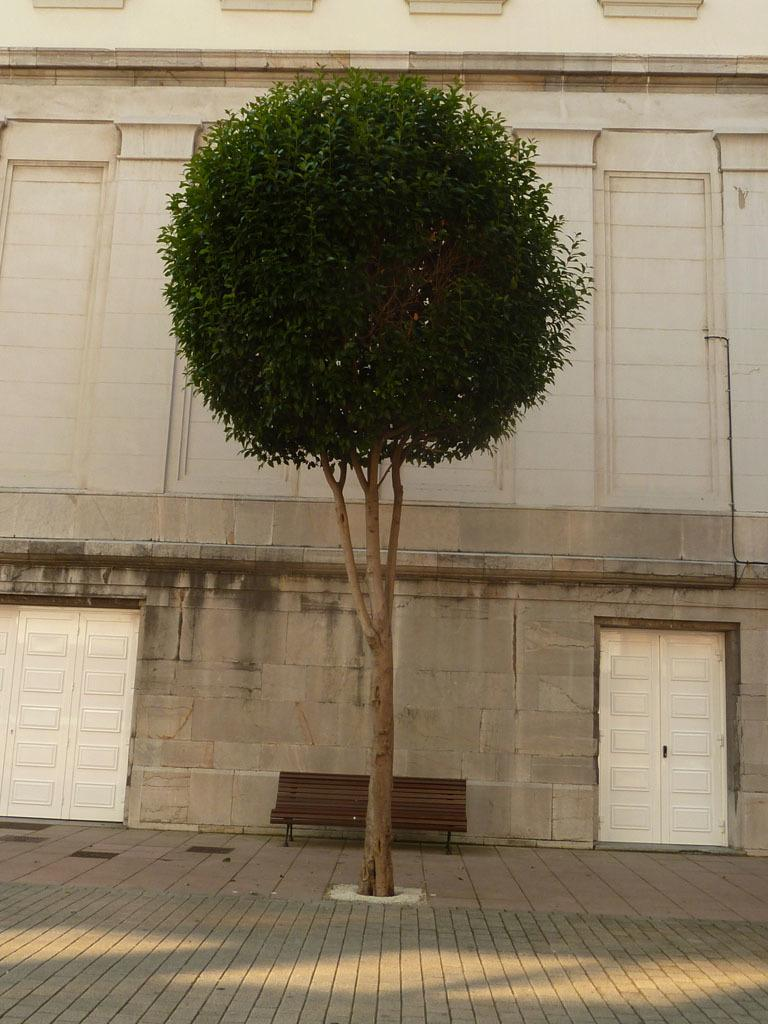What is located on the sidewalk in the image? There is a tree on a sidewalk in the image. What can be seen in the background of the image? There is a bench in the background. Are there any structures near the bench? Yes, there is a building with doors near the bench. What type of produce is being harvested with a rake near the tree? There is no produce or rake present in the image; it only features a tree on a sidewalk, a bench in the background, and a building with doors near the bench. 